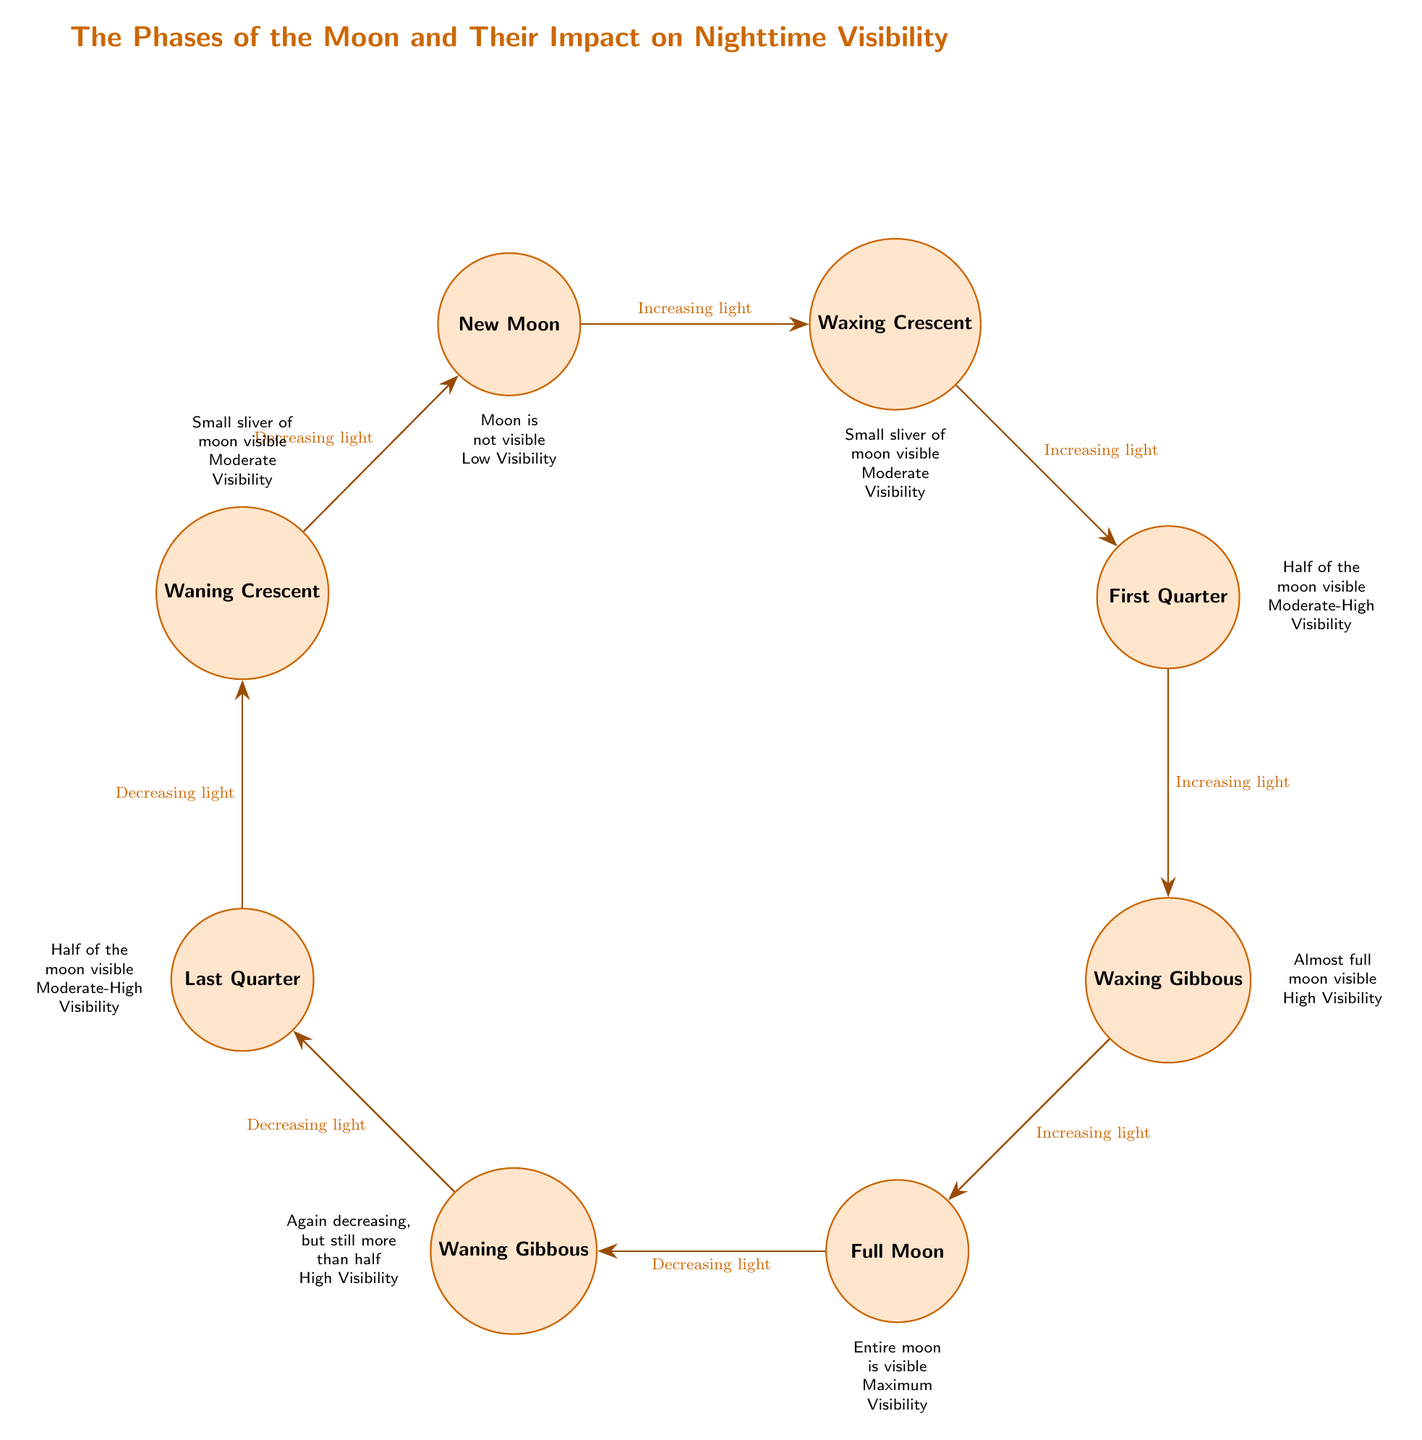What is the first phase of the moon shown in the diagram? The diagram starts with the "New Moon" positioned at the top left corner, which is the first phase of the moon as indicated.
Answer: New Moon How many total moon phases are displayed in the diagram? By counting the nodes labeled with moon phases, there are eight visible phases shown in the diagram.
Answer: Eight Which moon phase has maximum visibility? The "Full Moon" is clearly marked in the diagram as having maximum visibility, as described below it.
Answer: Full Moon What is the relationship between "Waxing Gibbous" and "Full Moon"? The diagram illustrates that the "Waxing Gibbous" phase transitions to the "Full Moon" with an edge labeled "Increasing light," indicating a progression in brightness.
Answer: Increasing light How is visibility rated during the "Last Quarter" phase? In the diagram, the "Last Quarter" phase is noted for having "Half of the moon visible," indicating that visibility is moderate-high.
Answer: Moderate-High Visibility What edge label is associated with the transition from "New Moon" to "Waxing Crescent"? The edge between the "New Moon" and "Waxing Crescent" is labeled "Increasing light," highlighting the gradual increase in visibility.
Answer: Increasing light Which phase shows a small sliver of the moon visible? The diagram shows both the "Waxing Crescent" and "Waning Crescent" phases as having a "Small sliver of moon visible."
Answer: Waxing Crescent, Waning Crescent What happens to the visibility after the "Full Moon"? The transition from "Full Moon" to "Waning Gibbous" is marked by the label "Decreasing light," indicating a reduction in visibility following the full phase.
Answer: Decreasing light 